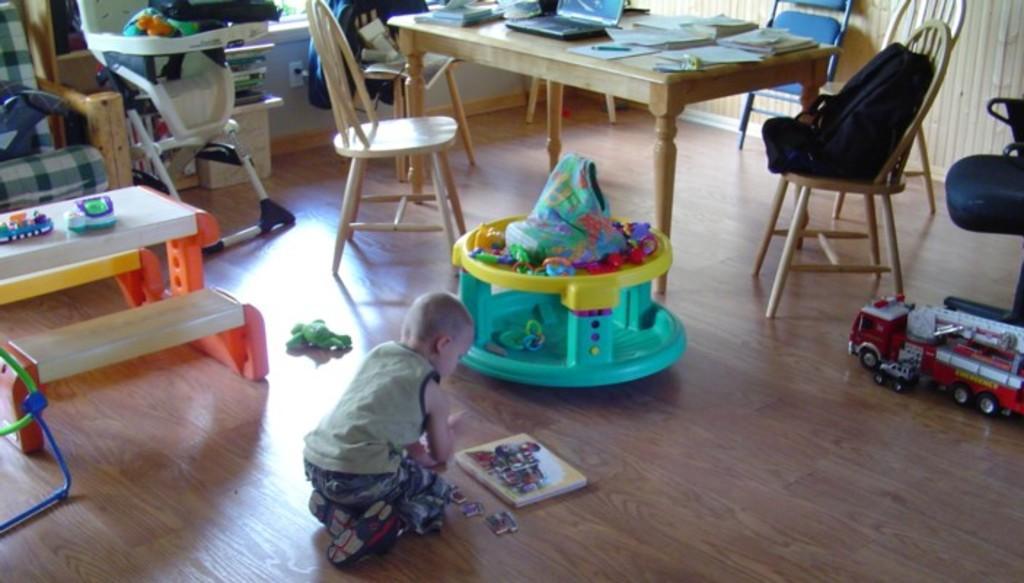In one or two sentences, can you explain what this image depicts? This picture shows a boy playing with toys and we see few chairs and a laptop and papers on the table and we see a Walker 